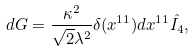Convert formula to latex. <formula><loc_0><loc_0><loc_500><loc_500>d G = \frac { \kappa ^ { 2 } } { \sqrt { 2 } \lambda ^ { 2 } } \delta ( x ^ { 1 1 } ) d x ^ { 1 1 } \hat { I _ { 4 } } ,</formula> 